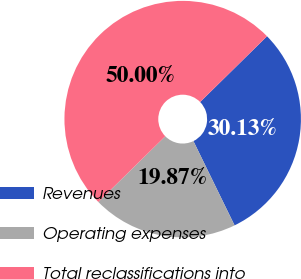Convert chart. <chart><loc_0><loc_0><loc_500><loc_500><pie_chart><fcel>Revenues<fcel>Operating expenses<fcel>Total reclassifications into<nl><fcel>30.13%<fcel>19.87%<fcel>50.0%<nl></chart> 